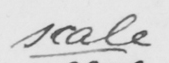Please transcribe the handwritten text in this image. scale 